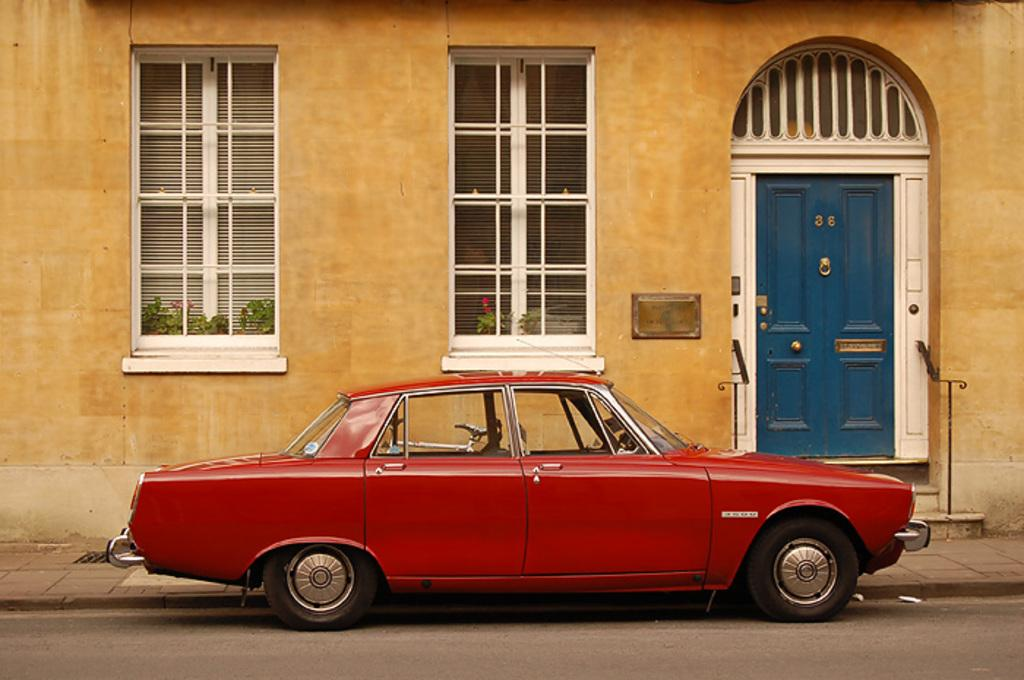What type of vehicle is in the image? There is a red car in the image. What can be seen in the background of the image? There is a bicycle in the background of the image. What is the color of the building in the image? There is a brown building in the image. How many windows are visible in the image? There are two windows in the image. What type of vegetation is present in the image? There are green plants in the image. What is the color of the door in the image? There is a blue door in the image. Can you see any water in the image? There is no water visible in the image. What type of fruit is being used to prop up the bicycle in the image? There is no fruit, such as a banana, present in the image to prop up the bicycle. 